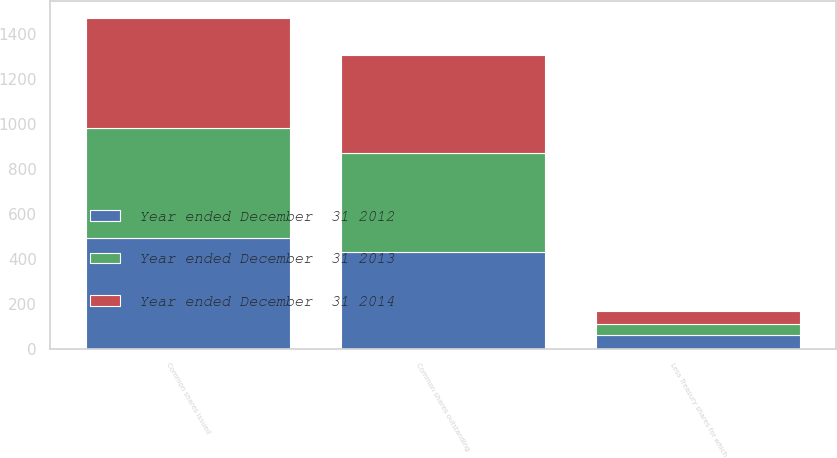<chart> <loc_0><loc_0><loc_500><loc_500><stacked_bar_chart><ecel><fcel>Common shares issued<fcel>Less Treasury shares for which<fcel>Common shares outstanding<nl><fcel>Year ended December  31 2012<fcel>490.4<fcel>60.5<fcel>429.9<nl><fcel>Year ended December  31 2014<fcel>490.4<fcel>57.3<fcel>433.1<nl><fcel>Year ended December  31 2013<fcel>490.4<fcel>49<fcel>441.4<nl></chart> 